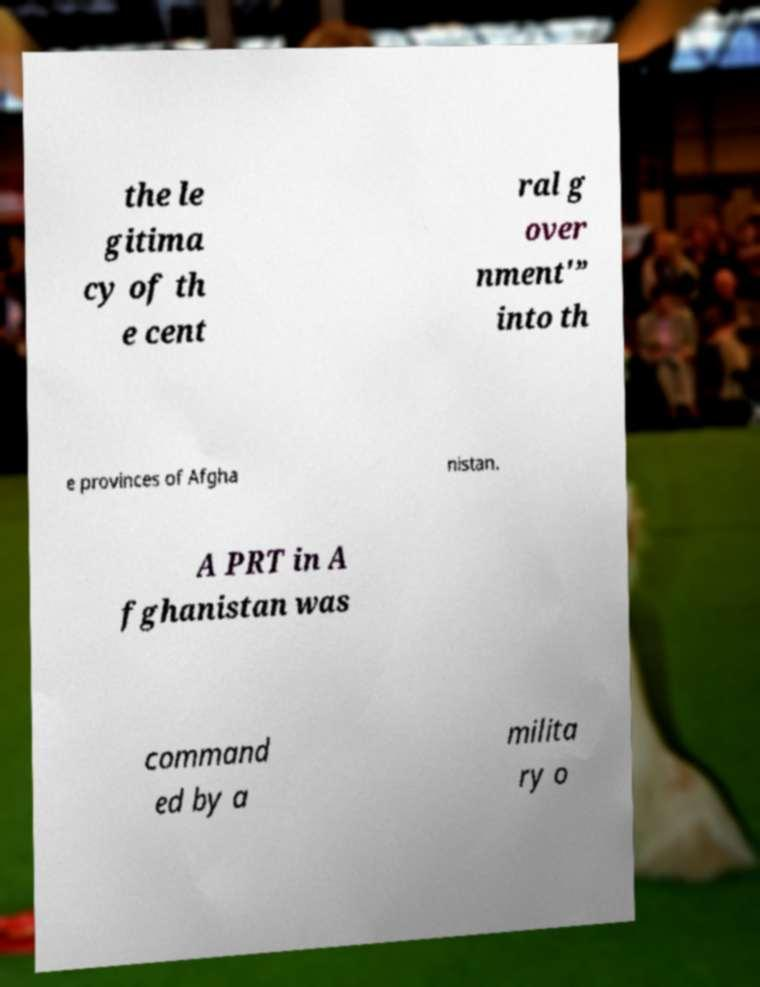I need the written content from this picture converted into text. Can you do that? the le gitima cy of th e cent ral g over nment'” into th e provinces of Afgha nistan. A PRT in A fghanistan was command ed by a milita ry o 